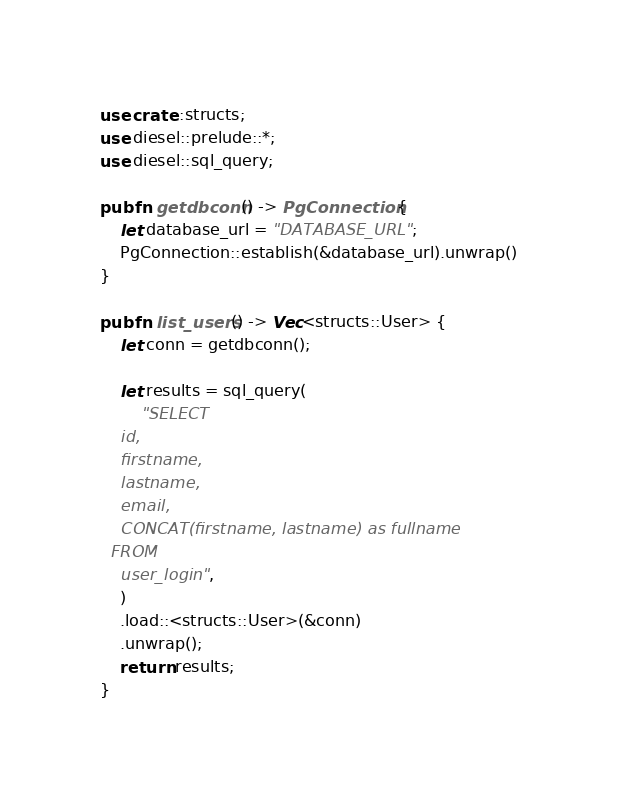Convert code to text. <code><loc_0><loc_0><loc_500><loc_500><_Rust_>use crate::structs;
use diesel::prelude::*;
use diesel::sql_query;

pub fn getdbconn() -> PgConnection {
    let database_url = "DATABASE_URL";
    PgConnection::establish(&database_url).unwrap()
}

pub fn list_users() -> Vec<structs::User> {
    let conn = getdbconn();

    let results = sql_query(
        "SELECT
    id,
    firstname,
    lastname,
    email,
    CONCAT(firstname, lastname) as fullname
  FROM
    user_login",
    )
    .load::<structs::User>(&conn)
    .unwrap();
    return results;
}
</code> 